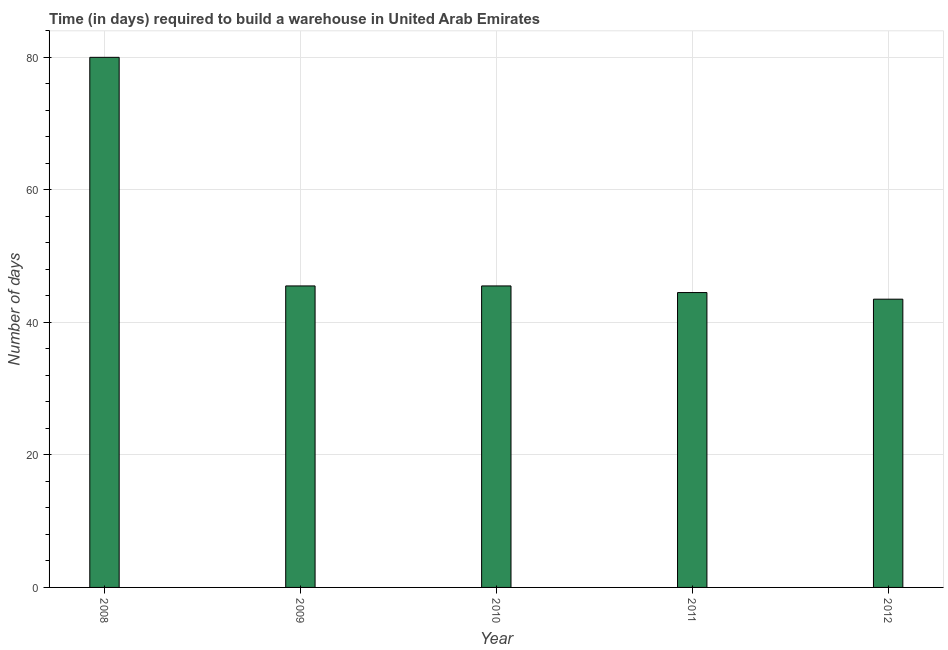Does the graph contain grids?
Keep it short and to the point. Yes. What is the title of the graph?
Your response must be concise. Time (in days) required to build a warehouse in United Arab Emirates. What is the label or title of the X-axis?
Keep it short and to the point. Year. What is the label or title of the Y-axis?
Your response must be concise. Number of days. What is the time required to build a warehouse in 2009?
Offer a very short reply. 45.5. Across all years, what is the maximum time required to build a warehouse?
Keep it short and to the point. 80. Across all years, what is the minimum time required to build a warehouse?
Offer a very short reply. 43.5. What is the sum of the time required to build a warehouse?
Keep it short and to the point. 259. What is the difference between the time required to build a warehouse in 2008 and 2012?
Ensure brevity in your answer.  36.5. What is the average time required to build a warehouse per year?
Offer a terse response. 51.8. What is the median time required to build a warehouse?
Provide a succinct answer. 45.5. In how many years, is the time required to build a warehouse greater than 48 days?
Make the answer very short. 1. Do a majority of the years between 2011 and 2010 (inclusive) have time required to build a warehouse greater than 48 days?
Ensure brevity in your answer.  No. What is the ratio of the time required to build a warehouse in 2008 to that in 2011?
Your answer should be very brief. 1.8. What is the difference between the highest and the second highest time required to build a warehouse?
Keep it short and to the point. 34.5. Is the sum of the time required to build a warehouse in 2009 and 2010 greater than the maximum time required to build a warehouse across all years?
Provide a succinct answer. Yes. What is the difference between the highest and the lowest time required to build a warehouse?
Offer a very short reply. 36.5. How many years are there in the graph?
Make the answer very short. 5. What is the Number of days in 2009?
Give a very brief answer. 45.5. What is the Number of days of 2010?
Provide a short and direct response. 45.5. What is the Number of days of 2011?
Offer a very short reply. 44.5. What is the Number of days of 2012?
Keep it short and to the point. 43.5. What is the difference between the Number of days in 2008 and 2009?
Give a very brief answer. 34.5. What is the difference between the Number of days in 2008 and 2010?
Keep it short and to the point. 34.5. What is the difference between the Number of days in 2008 and 2011?
Make the answer very short. 35.5. What is the difference between the Number of days in 2008 and 2012?
Provide a short and direct response. 36.5. What is the difference between the Number of days in 2009 and 2010?
Your answer should be very brief. 0. What is the ratio of the Number of days in 2008 to that in 2009?
Keep it short and to the point. 1.76. What is the ratio of the Number of days in 2008 to that in 2010?
Ensure brevity in your answer.  1.76. What is the ratio of the Number of days in 2008 to that in 2011?
Keep it short and to the point. 1.8. What is the ratio of the Number of days in 2008 to that in 2012?
Provide a short and direct response. 1.84. What is the ratio of the Number of days in 2009 to that in 2011?
Your answer should be compact. 1.02. What is the ratio of the Number of days in 2009 to that in 2012?
Offer a terse response. 1.05. What is the ratio of the Number of days in 2010 to that in 2012?
Your answer should be compact. 1.05. 